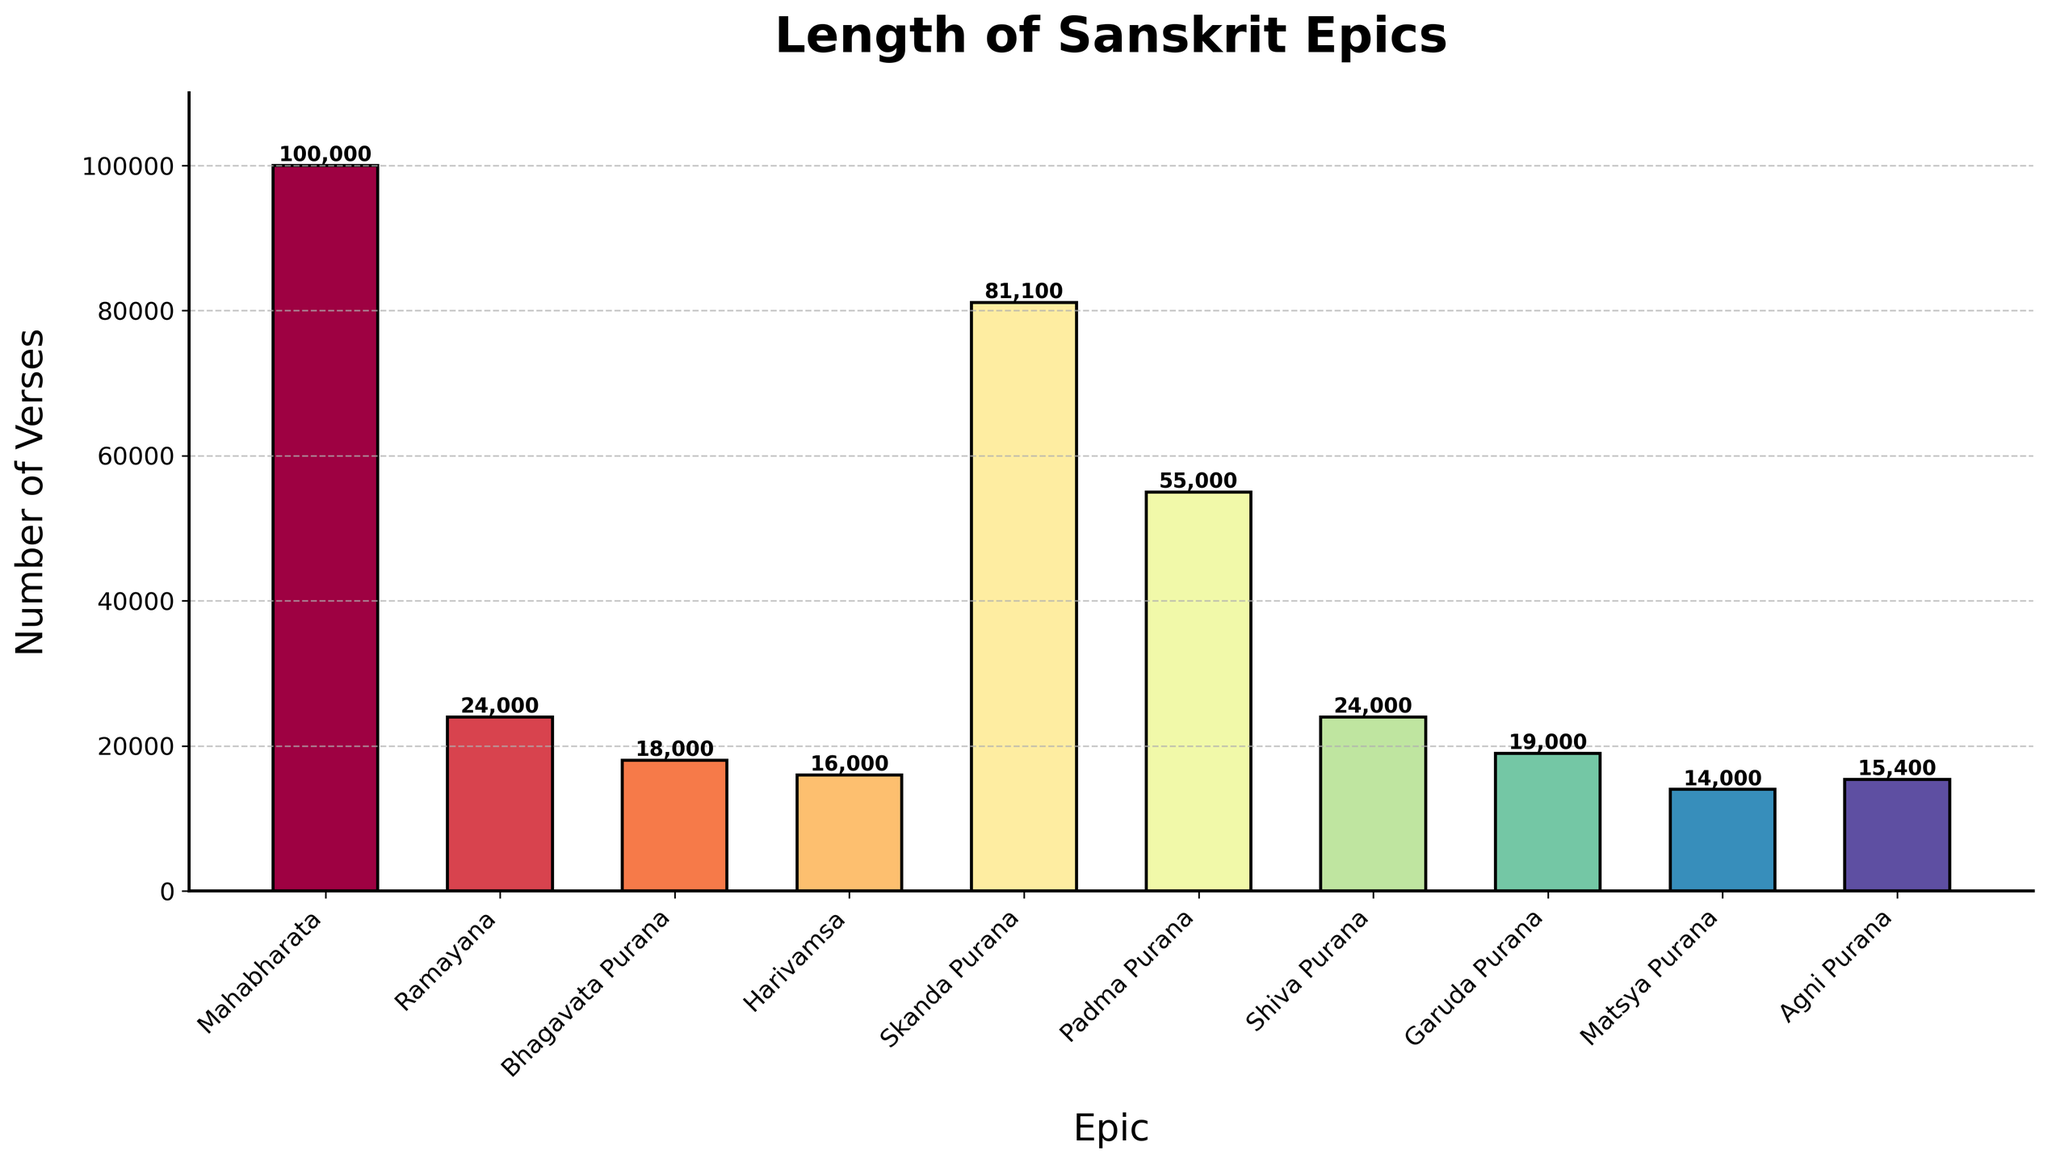1. Which epic has the highest number of verses? The bar with the tallest height represents the epic with the highest number of verses. From the figure, it is clear that the Mahabharata has the tallest bar.
Answer: Mahabharata 2. Which epic has the lowest number of verses? The bar with the shortest height represents the epic with the lowest number of verses. The figure shows that the Matsya Purana has the shortest bar.
Answer: Matsya Purana 3. How many epics have more than 50,000 verses? By observing the heights of the bars and referring to their corresponding values, we can count the number of epics with more than 50,000 verses. There are two such epics: Mahabharata (100,000) and Skanda Purana (81,100).
Answer: 2 4. What is the combined total number of verses for Mahabharata and Ramayana? Adding the number of verses for Mahabharata (100,000) and Ramayana (24,000) gives the combined total. So, 100,000 + 24,000 = 124,000.
Answer: 124,000 5. Compare the number of verses in the Skanda Purana and Padma Purana. Which one has more? By comparing the heights of the bars and their corresponding values, the Skanda Purana (81,100 verses) is greater than the Padma Purana (55,000 verses).
Answer: Skanda Purana 6. What is the average number of verses across all the listed Sanskrit epics? To find the average, sum all the verses and divide by the number of epics. Total verses = 100,000 + 24,000 + 18,000 + 16,000 + 81,100 + 55,000 + 24,000 + 19,000 + 14,000 + 15,400 = 366,500. Number of epics = 10. So, average = 366,500 / 10 = 36,650.
Answer: 36,650 7. What percentage of the total verses is accounted for by the Skanda Purana? First, find the total number of verses (366,500), then calculate the percentage that Skanda Purana's verses (81,100) contribute. (81,100 / 366,500) * 100 ≈ 22.12%.
Answer: ~22.12% 8. What is the difference in the number of verses between the Padma Purana and Garuda Purana? Subtract the number of verses in Garuda Purana (19,000) from Padma Purana (55,000). So, 55,000 - 19,000 = 36,000.
Answer: 36,000 9. Identify the colors used for the bars of the Ramayana and Agni Purana. Visually inspect the colors of the bars representing Ramayana and Agni Purana. From the Spectral colormap in the figure, the colors are unique and easily distinguishable but must be described through direct observation.
Answer: (Color descriptions based on visual inspection) 10. How many epics have fewer verses than the Agni Purana? Identify the number of bars shorter than or equal to the height of Agni Purana, which has 15,400 verses. There is only one such epic: Matsya Purana (14,000 verses).
Answer: 1 